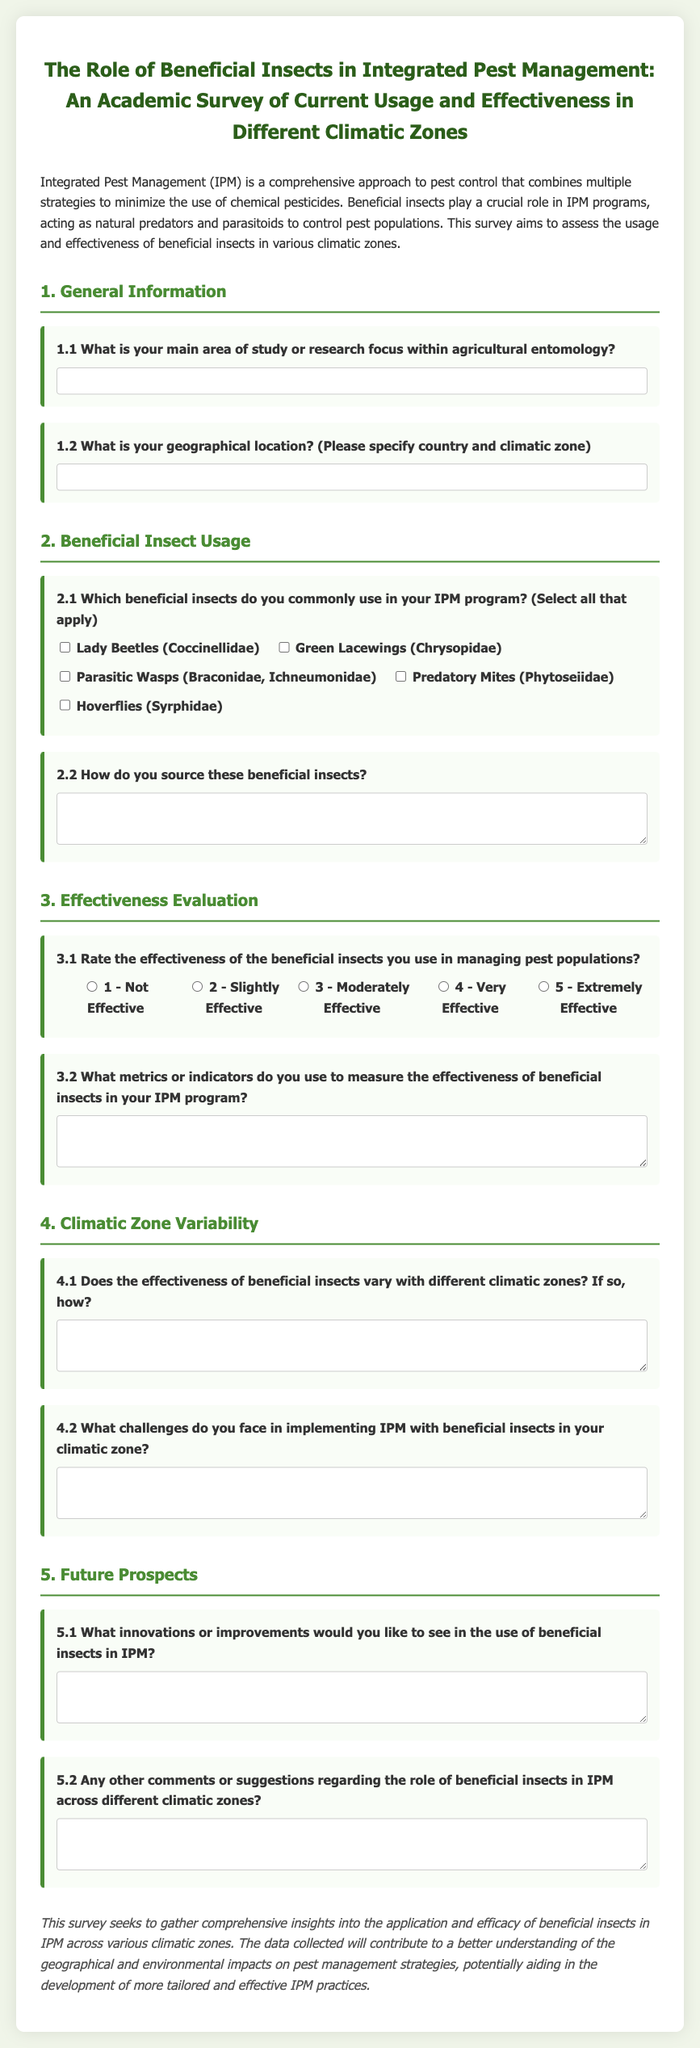what is the title of the survey? The title of the survey is mentioned at the top of the document, summarizing its focus on beneficial insects and integrated pest management.
Answer: The Role of Beneficial Insects in Integrated Pest Management: An Academic Survey of Current Usage and Effectiveness in Different Climatic Zones which section discusses general information? The section that covers general information is indicated with a heading, establishing the context for the questions that follow.
Answer: 1. General Information name one type of beneficial insect mentioned in the survey. The survey lists various beneficial insects as options in the second section, indicating their relevance to IPM.
Answer: Lady Beetles how do respondents source beneficial insects? The survey prompts respondents to provide details about their sourcing methods in the linked question, reflecting their practices.
Answer: Sourcing methods what effectiveness rating is the lowest possible in the scale? The effectiveness ratings are presented in a Likert scale format, showing the range from not effective to extremely effective.
Answer: 1 - Not Effective what does the survey aim to assess? The purpose of the survey, described in the opening paragraphs, focuses on evaluating the role of beneficial insects in pest management across different environments.
Answer: Usage and effectiveness of beneficial insects what kind of challenges are addressed in the survey? The survey includes specific inquiries aimed at understanding obstacles faced by respondents when employing beneficial insects in their IPM practices.
Answer: Challenges in implementing IPM what primary aspect does the last section of the survey focus on? The final section of the survey seeks to explore future innovations and improvements, inviting feedback on potential advancements in IPM strategies.
Answer: Future Prospects 